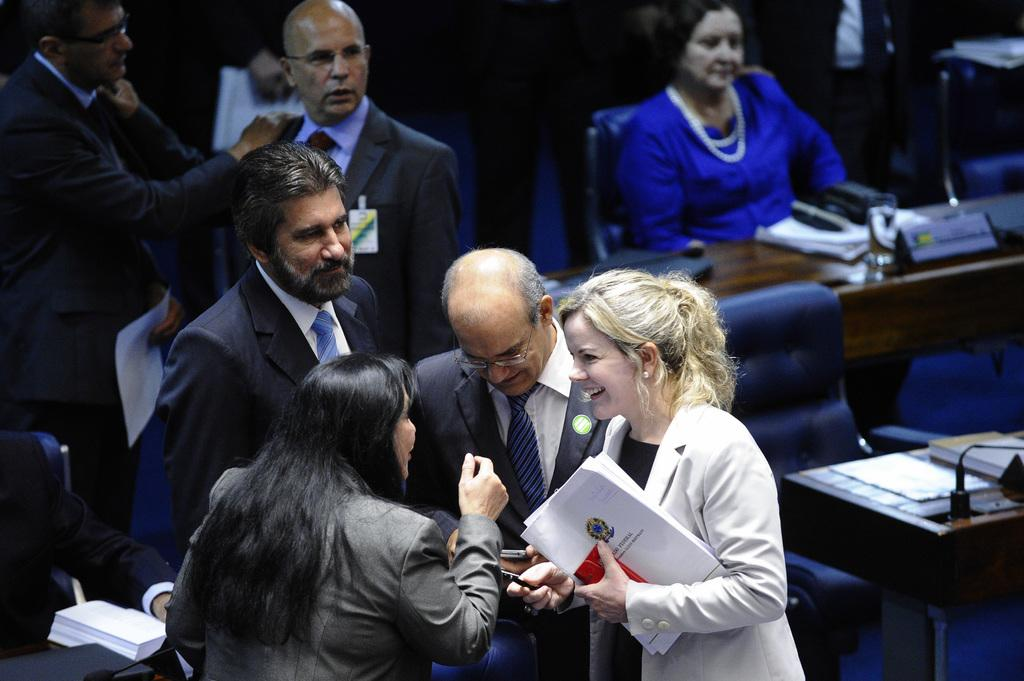What are the people in the image doing? There are persons standing and sitting in the image. Can you describe the objects that the people are using or interacting with? One person is holding a book, and a microphone is present on a table. What type of furniture is visible in the image? There are tables and chairs in the image. What else can be seen on the table? Name boards and other things are visible on the table. How much pain do the people in the image feel? There is no indication of pain or discomfort in the image; the people appear to be engaged in various activities. 